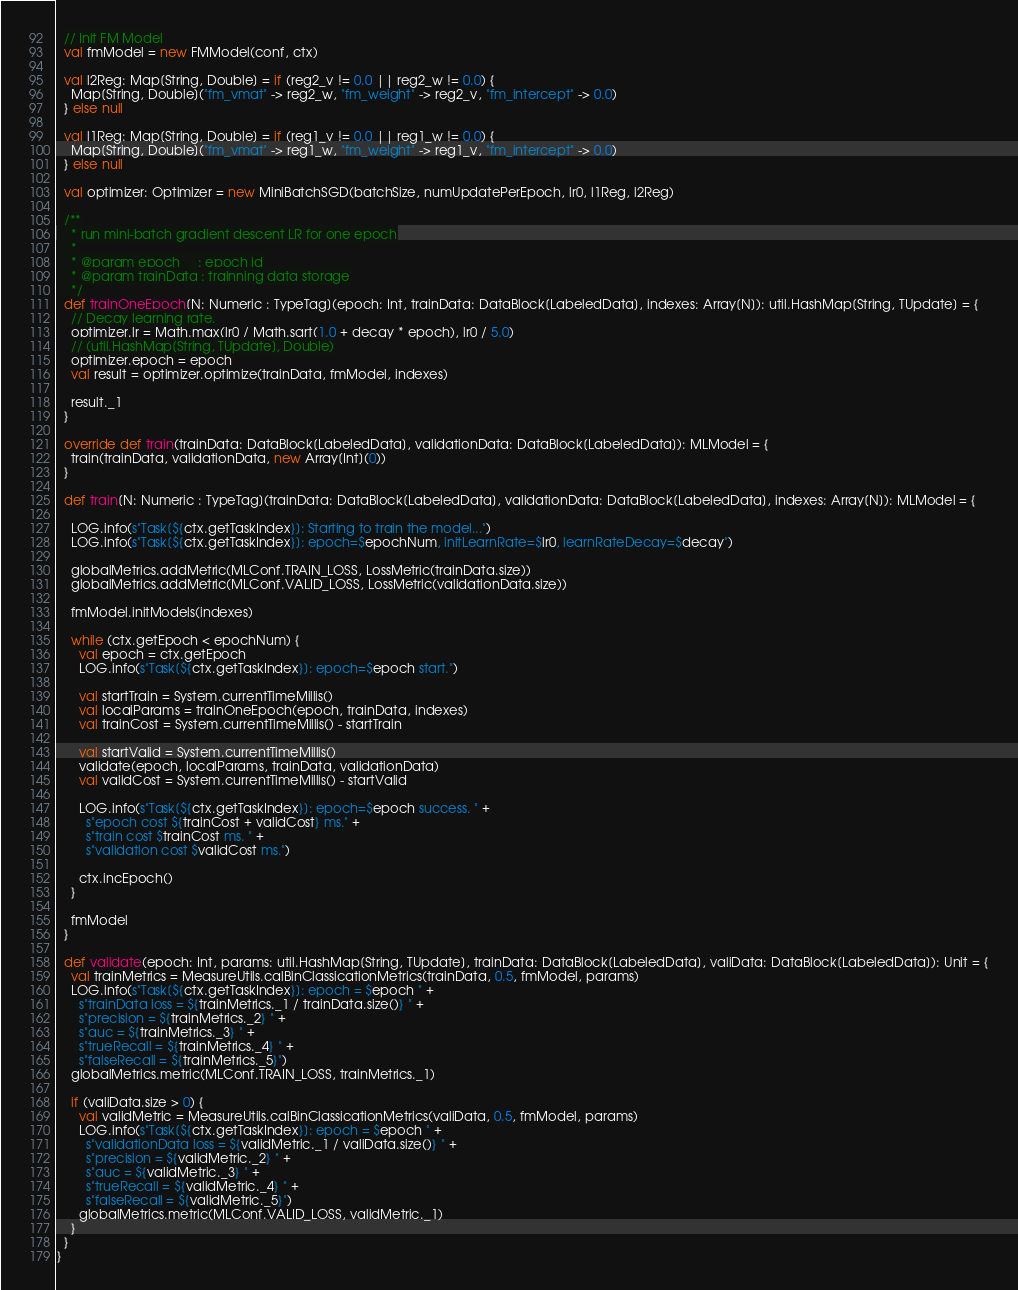<code> <loc_0><loc_0><loc_500><loc_500><_Scala_>  // Init FM Model
  val fmModel = new FMModel(conf, ctx)

  val l2Reg: Map[String, Double] = if (reg2_v != 0.0 || reg2_w != 0.0) {
    Map[String, Double]("fm_vmat" -> reg2_w, "fm_weight" -> reg2_v, "fm_intercept" -> 0.0)
  } else null

  val l1Reg: Map[String, Double] = if (reg1_v != 0.0 || reg1_w != 0.0) {
    Map[String, Double]("fm_vmat" -> reg1_w, "fm_weight" -> reg1_v, "fm_intercept" -> 0.0)
  } else null

  val optimizer: Optimizer = new MiniBatchSGD(batchSize, numUpdatePerEpoch, lr0, l1Reg, l2Reg)

  /**
    * run mini-batch gradient descent LR for one epoch
    *
    * @param epoch     : epoch id
    * @param trainData : trainning data storage
    */
  def trainOneEpoch[N: Numeric : TypeTag](epoch: Int, trainData: DataBlock[LabeledData], indexes: Array[N]): util.HashMap[String, TUpdate] = {
    // Decay learning rate.
    optimizer.lr = Math.max(lr0 / Math.sqrt(1.0 + decay * epoch), lr0 / 5.0)
    // (util.HashMap[String, TUpdate], Double)
    optimizer.epoch = epoch
    val result = optimizer.optimize(trainData, fmModel, indexes)

    result._1
  }

  override def train(trainData: DataBlock[LabeledData], validationData: DataBlock[LabeledData]): MLModel = {
    train(trainData, validationData, new Array[Int](0))
  }

  def train[N: Numeric : TypeTag](trainData: DataBlock[LabeledData], validationData: DataBlock[LabeledData], indexes: Array[N]): MLModel = {

    LOG.info(s"Task[${ctx.getTaskIndex}]: Starting to train the model...")
    LOG.info(s"Task[${ctx.getTaskIndex}]: epoch=$epochNum, initLearnRate=$lr0, learnRateDecay=$decay")

    globalMetrics.addMetric(MLConf.TRAIN_LOSS, LossMetric(trainData.size))
    globalMetrics.addMetric(MLConf.VALID_LOSS, LossMetric(validationData.size))

    fmModel.initModels(indexes)

    while (ctx.getEpoch < epochNum) {
      val epoch = ctx.getEpoch
      LOG.info(s"Task[${ctx.getTaskIndex}]: epoch=$epoch start.")

      val startTrain = System.currentTimeMillis()
      val localParams = trainOneEpoch(epoch, trainData, indexes)
      val trainCost = System.currentTimeMillis() - startTrain

      val startValid = System.currentTimeMillis()
      validate(epoch, localParams, trainData, validationData)
      val validCost = System.currentTimeMillis() - startValid

      LOG.info(s"Task[${ctx.getTaskIndex}]: epoch=$epoch success. " +
        s"epoch cost ${trainCost + validCost} ms." +
        s"train cost $trainCost ms. " +
        s"validation cost $validCost ms.")

      ctx.incEpoch()
    }

    fmModel
  }

  def validate(epoch: Int, params: util.HashMap[String, TUpdate], trainData: DataBlock[LabeledData], valiData: DataBlock[LabeledData]): Unit = {
    val trainMetrics = MeasureUtils.calBinClassicationMetrics(trainData, 0.5, fmModel, params)
    LOG.info(s"Task[${ctx.getTaskIndex}]: epoch = $epoch " +
      s"trainData loss = ${trainMetrics._1 / trainData.size()} " +
      s"precision = ${trainMetrics._2} " +
      s"auc = ${trainMetrics._3} " +
      s"trueRecall = ${trainMetrics._4} " +
      s"falseRecall = ${trainMetrics._5}")
    globalMetrics.metric(MLConf.TRAIN_LOSS, trainMetrics._1)

    if (valiData.size > 0) {
      val validMetric = MeasureUtils.calBinClassicationMetrics(valiData, 0.5, fmModel, params)
      LOG.info(s"Task[${ctx.getTaskIndex}]: epoch = $epoch " +
        s"validationData loss = ${validMetric._1 / valiData.size()} " +
        s"precision = ${validMetric._2} " +
        s"auc = ${validMetric._3} " +
        s"trueRecall = ${validMetric._4} " +
        s"falseRecall = ${validMetric._5}")
      globalMetrics.metric(MLConf.VALID_LOSS, validMetric._1)
    }
  }
}
</code> 